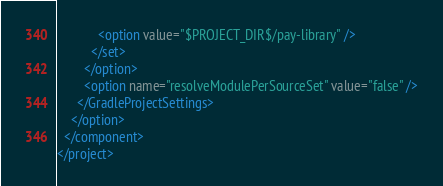Convert code to text. <code><loc_0><loc_0><loc_500><loc_500><_XML_>            <option value="$PROJECT_DIR$/pay-library" />
          </set>
        </option>
        <option name="resolveModulePerSourceSet" value="false" />
      </GradleProjectSettings>
    </option>
  </component>
</project></code> 